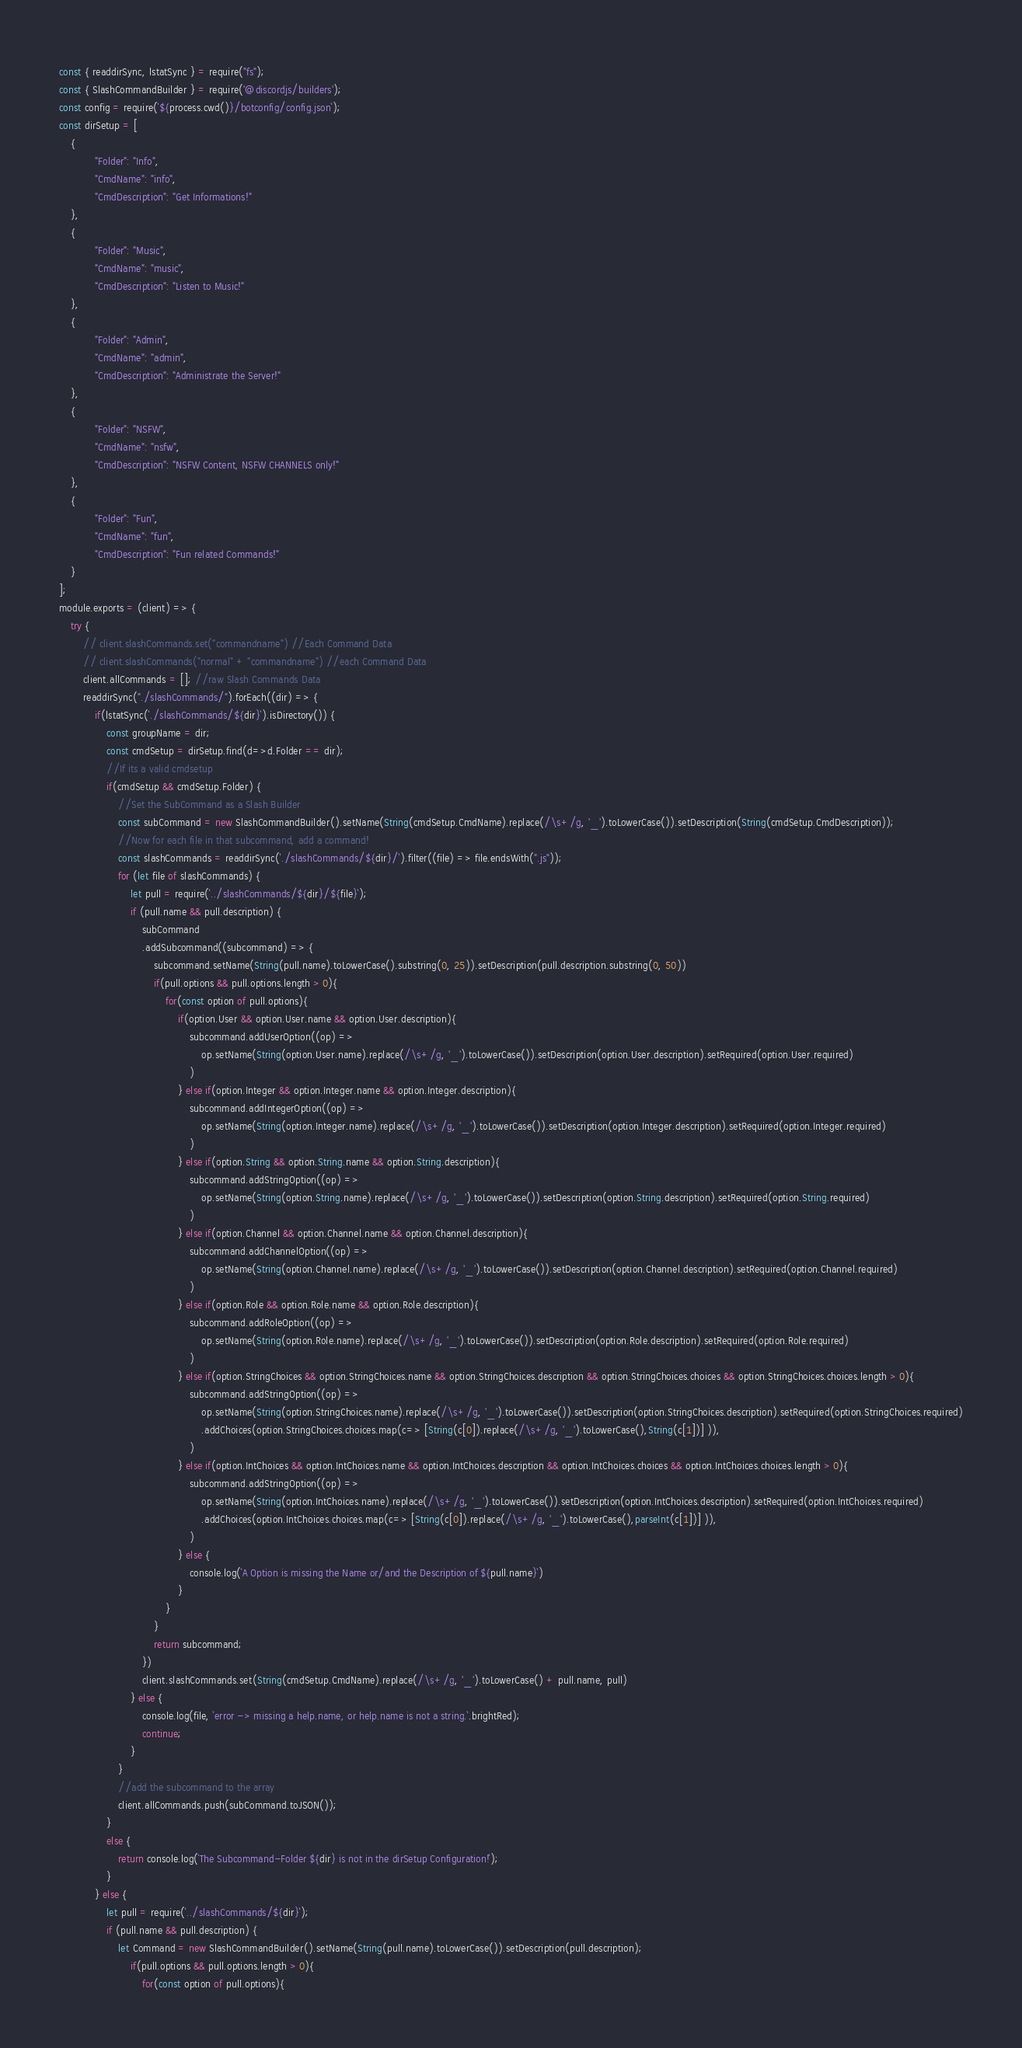Convert code to text. <code><loc_0><loc_0><loc_500><loc_500><_JavaScript_>const { readdirSync, lstatSync } = require("fs");
const { SlashCommandBuilder } = require('@discordjs/builders');
const config = require(`${process.cwd()}/botconfig/config.json`);
const dirSetup = [
    {
            "Folder": "Info",
            "CmdName": "info",
            "CmdDescription": "Get Informations!"
    },
    {
            "Folder": "Music",
            "CmdName": "music",
            "CmdDescription": "Listen to Music!"
    },
    {
            "Folder": "Admin",
            "CmdName": "admin",
            "CmdDescription": "Administrate the Server!"
    },
    {
            "Folder": "NSFW",
            "CmdName": "nsfw",
            "CmdDescription": "NSFW Content, NSFW CHANNELS only!"
    },
    {
            "Folder": "Fun",
            "CmdName": "fun",
            "CmdDescription": "Fun related Commands!"
    }
];
module.exports = (client) => {
    try {
		// client.slashCommands.set("commandname") //Each Command Data
		// client.slashCommands("normal" + "commandname") //each Command Data
		client.allCommands = []; //raw Slash Commands Data
        readdirSync("./slashCommands/").forEach((dir) => {
			if(lstatSync(`./slashCommands/${dir}`).isDirectory()) {
				const groupName = dir;
				const cmdSetup = dirSetup.find(d=>d.Folder == dir);
				//If its a valid cmdsetup
				if(cmdSetup && cmdSetup.Folder) {
					//Set the SubCommand as a Slash Builder
					const subCommand = new SlashCommandBuilder().setName(String(cmdSetup.CmdName).replace(/\s+/g, '_').toLowerCase()).setDescription(String(cmdSetup.CmdDescription));
					//Now for each file in that subcommand, add a command!
					const slashCommands = readdirSync(`./slashCommands/${dir}/`).filter((file) => file.endsWith(".js"));
					for (let file of slashCommands) {
						let pull = require(`../slashCommands/${dir}/${file}`);
						if (pull.name && pull.description) {
							subCommand
							.addSubcommand((subcommand) => {
								subcommand.setName(String(pull.name).toLowerCase().substring(0, 25)).setDescription(pull.description.substring(0, 50))
								if(pull.options && pull.options.length > 0){
									for(const option of pull.options){
										if(option.User && option.User.name && option.User.description){
											subcommand.addUserOption((op) =>
												op.setName(String(option.User.name).replace(/\s+/g, '_').toLowerCase()).setDescription(option.User.description).setRequired(option.User.required)
											)
										} else if(option.Integer && option.Integer.name && option.Integer.description){
											subcommand.addIntegerOption((op) =>
												op.setName(String(option.Integer.name).replace(/\s+/g, '_').toLowerCase()).setDescription(option.Integer.description).setRequired(option.Integer.required)
											)
										} else if(option.String && option.String.name && option.String.description){
											subcommand.addStringOption((op) =>
												op.setName(String(option.String.name).replace(/\s+/g, '_').toLowerCase()).setDescription(option.String.description).setRequired(option.String.required)
											)
										} else if(option.Channel && option.Channel.name && option.Channel.description){
											subcommand.addChannelOption((op) =>
												op.setName(String(option.Channel.name).replace(/\s+/g, '_').toLowerCase()).setDescription(option.Channel.description).setRequired(option.Channel.required)
											)
										} else if(option.Role && option.Role.name && option.Role.description){
											subcommand.addRoleOption((op) =>
												op.setName(String(option.Role.name).replace(/\s+/g, '_').toLowerCase()).setDescription(option.Role.description).setRequired(option.Role.required)
											)
										} else if(option.StringChoices && option.StringChoices.name && option.StringChoices.description && option.StringChoices.choices && option.StringChoices.choices.length > 0){
											subcommand.addStringOption((op) =>
												op.setName(String(option.StringChoices.name).replace(/\s+/g, '_').toLowerCase()).setDescription(option.StringChoices.description).setRequired(option.StringChoices.required)
												.addChoices(option.StringChoices.choices.map(c=> [String(c[0]).replace(/\s+/g, '_').toLowerCase(),String(c[1])] )),
											)
										} else if(option.IntChoices && option.IntChoices.name && option.IntChoices.description && option.IntChoices.choices && option.IntChoices.choices.length > 0){
											subcommand.addStringOption((op) =>
												op.setName(String(option.IntChoices.name).replace(/\s+/g, '_').toLowerCase()).setDescription(option.IntChoices.description).setRequired(option.IntChoices.required)
												.addChoices(option.IntChoices.choices.map(c=> [String(c[0]).replace(/\s+/g, '_').toLowerCase(),parseInt(c[1])] )),
											)
										} else {
											console.log(`A Option is missing the Name or/and the Description of ${pull.name}`)
										}
									}
								}
								return subcommand;
							})
							client.slashCommands.set(String(cmdSetup.CmdName).replace(/\s+/g, '_').toLowerCase() + pull.name, pull)
						} else {
							console.log(file, `error -> missing a help.name, or help.name is not a string.`.brightRed);
							continue;
						}
					}
					//add the subcommand to the array
					client.allCommands.push(subCommand.toJSON());
				} 
				else {
					return console.log(`The Subcommand-Folder ${dir} is not in the dirSetup Configuration!`);
				}
			} else {
				let pull = require(`../slashCommands/${dir}`);
				if (pull.name && pull.description) {
					let Command = new SlashCommandBuilder().setName(String(pull.name).toLowerCase()).setDescription(pull.description);
						if(pull.options && pull.options.length > 0){
							for(const option of pull.options){</code> 